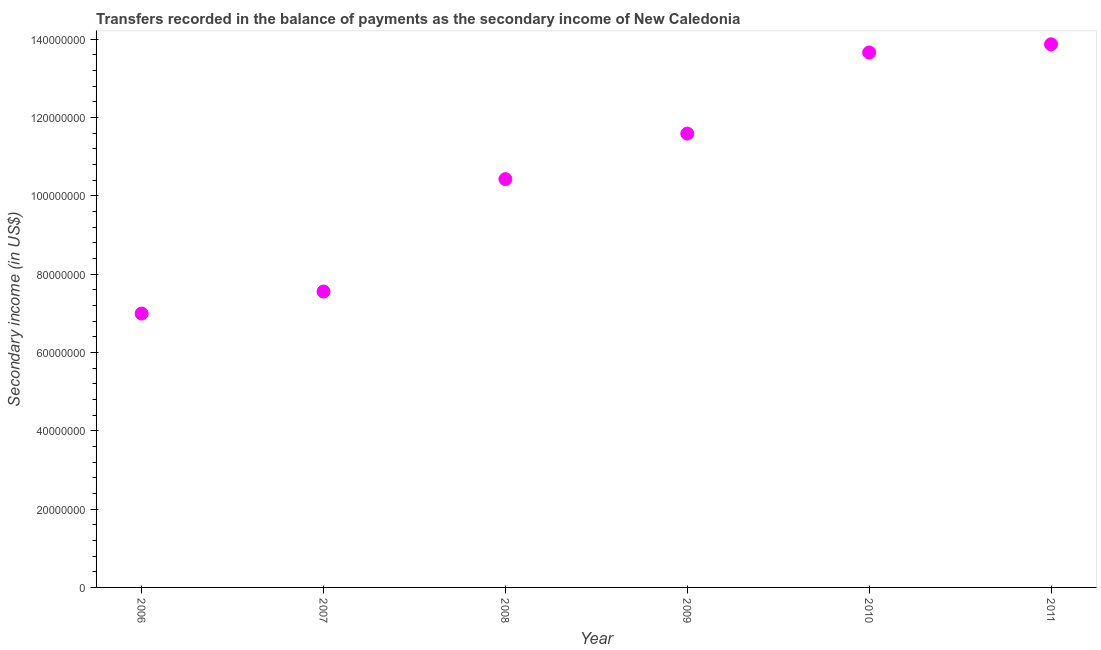What is the amount of secondary income in 2006?
Give a very brief answer. 6.99e+07. Across all years, what is the maximum amount of secondary income?
Give a very brief answer. 1.39e+08. Across all years, what is the minimum amount of secondary income?
Make the answer very short. 6.99e+07. What is the sum of the amount of secondary income?
Give a very brief answer. 6.41e+08. What is the difference between the amount of secondary income in 2007 and 2009?
Your response must be concise. -4.03e+07. What is the average amount of secondary income per year?
Offer a terse response. 1.07e+08. What is the median amount of secondary income?
Make the answer very short. 1.10e+08. Do a majority of the years between 2007 and 2006 (inclusive) have amount of secondary income greater than 136000000 US$?
Your answer should be compact. No. What is the ratio of the amount of secondary income in 2009 to that in 2010?
Offer a very short reply. 0.85. Is the difference between the amount of secondary income in 2010 and 2011 greater than the difference between any two years?
Provide a succinct answer. No. What is the difference between the highest and the second highest amount of secondary income?
Your answer should be very brief. 2.09e+06. What is the difference between the highest and the lowest amount of secondary income?
Make the answer very short. 6.87e+07. Does the amount of secondary income monotonically increase over the years?
Provide a short and direct response. Yes. How many dotlines are there?
Offer a very short reply. 1. How many years are there in the graph?
Give a very brief answer. 6. Does the graph contain any zero values?
Ensure brevity in your answer.  No. Does the graph contain grids?
Give a very brief answer. No. What is the title of the graph?
Make the answer very short. Transfers recorded in the balance of payments as the secondary income of New Caledonia. What is the label or title of the X-axis?
Make the answer very short. Year. What is the label or title of the Y-axis?
Make the answer very short. Secondary income (in US$). What is the Secondary income (in US$) in 2006?
Give a very brief answer. 6.99e+07. What is the Secondary income (in US$) in 2007?
Your answer should be very brief. 7.55e+07. What is the Secondary income (in US$) in 2008?
Offer a very short reply. 1.04e+08. What is the Secondary income (in US$) in 2009?
Offer a terse response. 1.16e+08. What is the Secondary income (in US$) in 2010?
Give a very brief answer. 1.37e+08. What is the Secondary income (in US$) in 2011?
Ensure brevity in your answer.  1.39e+08. What is the difference between the Secondary income (in US$) in 2006 and 2007?
Give a very brief answer. -5.62e+06. What is the difference between the Secondary income (in US$) in 2006 and 2008?
Provide a succinct answer. -3.43e+07. What is the difference between the Secondary income (in US$) in 2006 and 2009?
Keep it short and to the point. -4.59e+07. What is the difference between the Secondary income (in US$) in 2006 and 2010?
Your answer should be compact. -6.67e+07. What is the difference between the Secondary income (in US$) in 2006 and 2011?
Ensure brevity in your answer.  -6.87e+07. What is the difference between the Secondary income (in US$) in 2007 and 2008?
Your answer should be compact. -2.87e+07. What is the difference between the Secondary income (in US$) in 2007 and 2009?
Provide a short and direct response. -4.03e+07. What is the difference between the Secondary income (in US$) in 2007 and 2010?
Give a very brief answer. -6.10e+07. What is the difference between the Secondary income (in US$) in 2007 and 2011?
Offer a terse response. -6.31e+07. What is the difference between the Secondary income (in US$) in 2008 and 2009?
Your answer should be compact. -1.16e+07. What is the difference between the Secondary income (in US$) in 2008 and 2010?
Your answer should be very brief. -3.23e+07. What is the difference between the Secondary income (in US$) in 2008 and 2011?
Offer a terse response. -3.44e+07. What is the difference between the Secondary income (in US$) in 2009 and 2010?
Your answer should be very brief. -2.07e+07. What is the difference between the Secondary income (in US$) in 2009 and 2011?
Your answer should be compact. -2.28e+07. What is the difference between the Secondary income (in US$) in 2010 and 2011?
Your answer should be compact. -2.09e+06. What is the ratio of the Secondary income (in US$) in 2006 to that in 2007?
Your answer should be very brief. 0.93. What is the ratio of the Secondary income (in US$) in 2006 to that in 2008?
Provide a short and direct response. 0.67. What is the ratio of the Secondary income (in US$) in 2006 to that in 2009?
Provide a succinct answer. 0.6. What is the ratio of the Secondary income (in US$) in 2006 to that in 2010?
Give a very brief answer. 0.51. What is the ratio of the Secondary income (in US$) in 2006 to that in 2011?
Make the answer very short. 0.5. What is the ratio of the Secondary income (in US$) in 2007 to that in 2008?
Provide a succinct answer. 0.72. What is the ratio of the Secondary income (in US$) in 2007 to that in 2009?
Offer a terse response. 0.65. What is the ratio of the Secondary income (in US$) in 2007 to that in 2010?
Keep it short and to the point. 0.55. What is the ratio of the Secondary income (in US$) in 2007 to that in 2011?
Ensure brevity in your answer.  0.55. What is the ratio of the Secondary income (in US$) in 2008 to that in 2009?
Offer a very short reply. 0.9. What is the ratio of the Secondary income (in US$) in 2008 to that in 2010?
Give a very brief answer. 0.76. What is the ratio of the Secondary income (in US$) in 2008 to that in 2011?
Your answer should be very brief. 0.75. What is the ratio of the Secondary income (in US$) in 2009 to that in 2010?
Offer a very short reply. 0.85. What is the ratio of the Secondary income (in US$) in 2009 to that in 2011?
Offer a terse response. 0.84. 